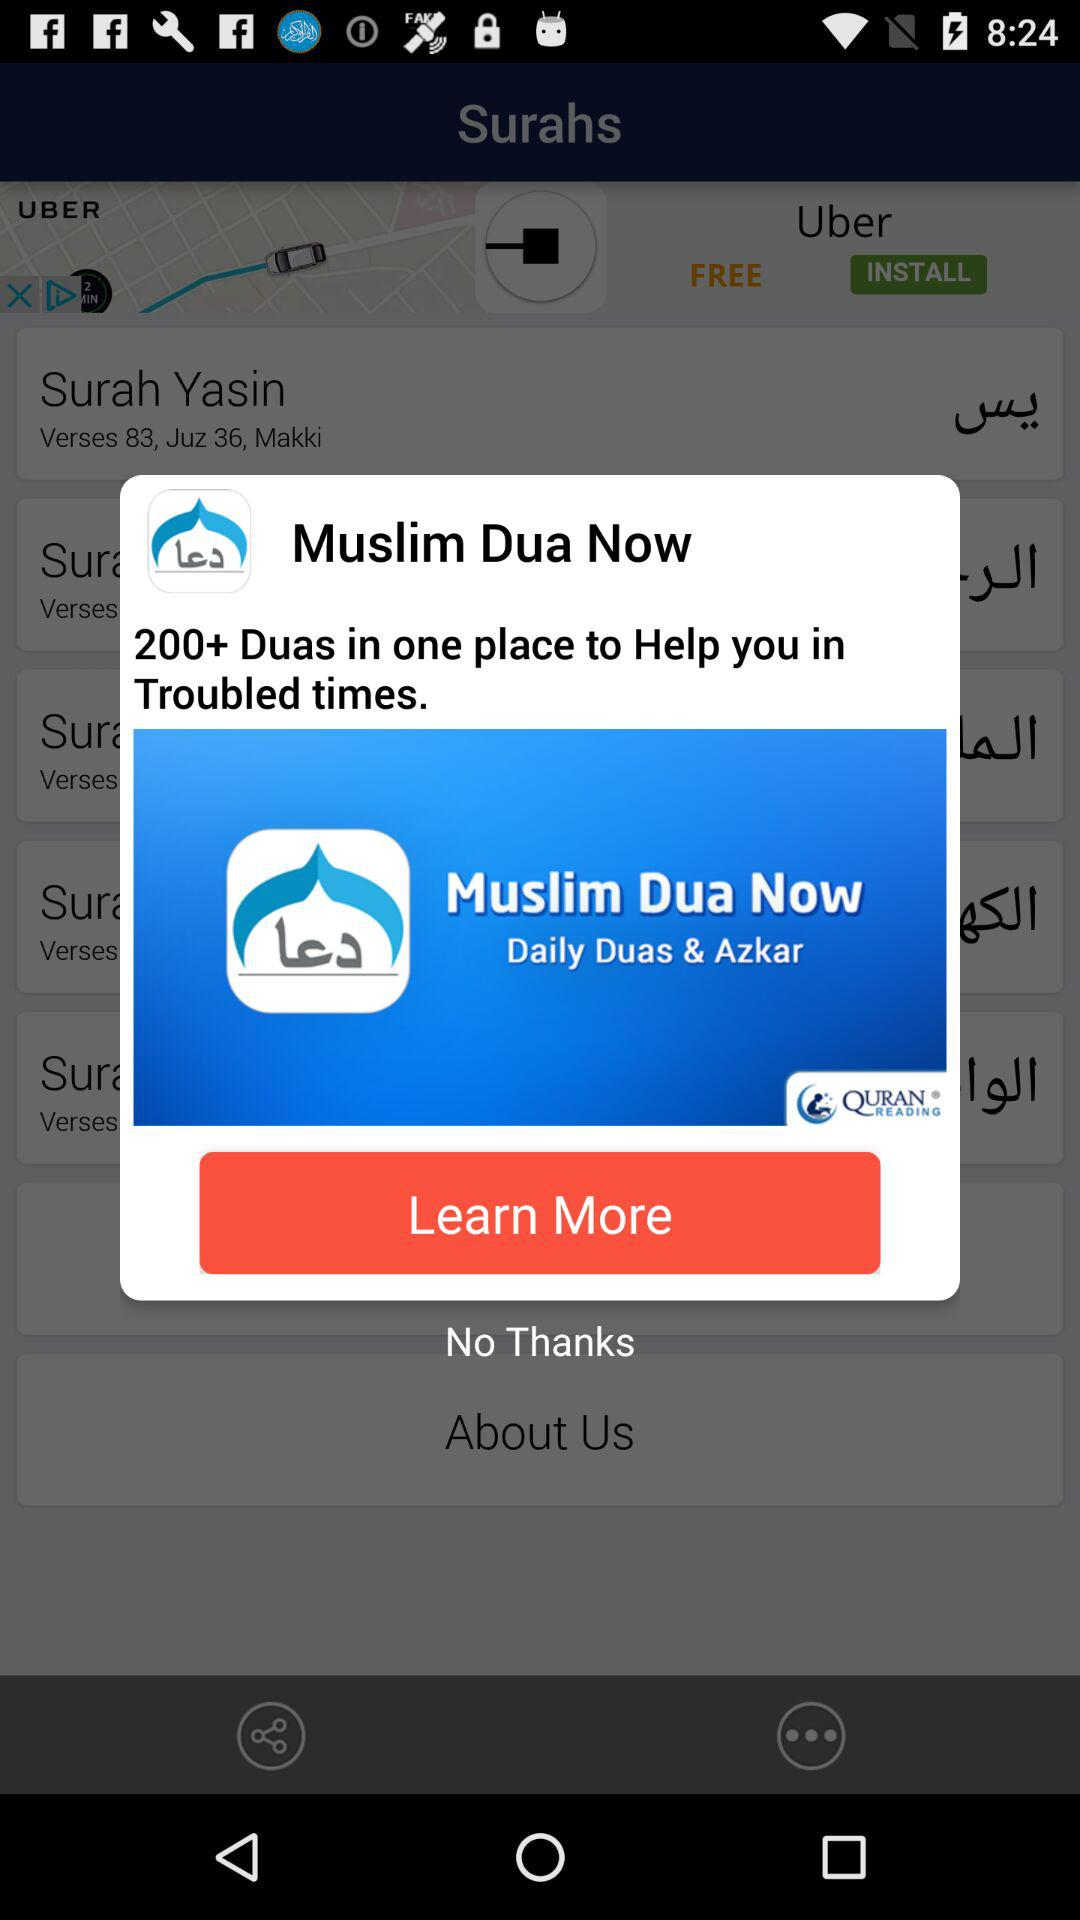What's the number of Duas helped in troubled times? There are 200+ Duas that helped in troubled times. 